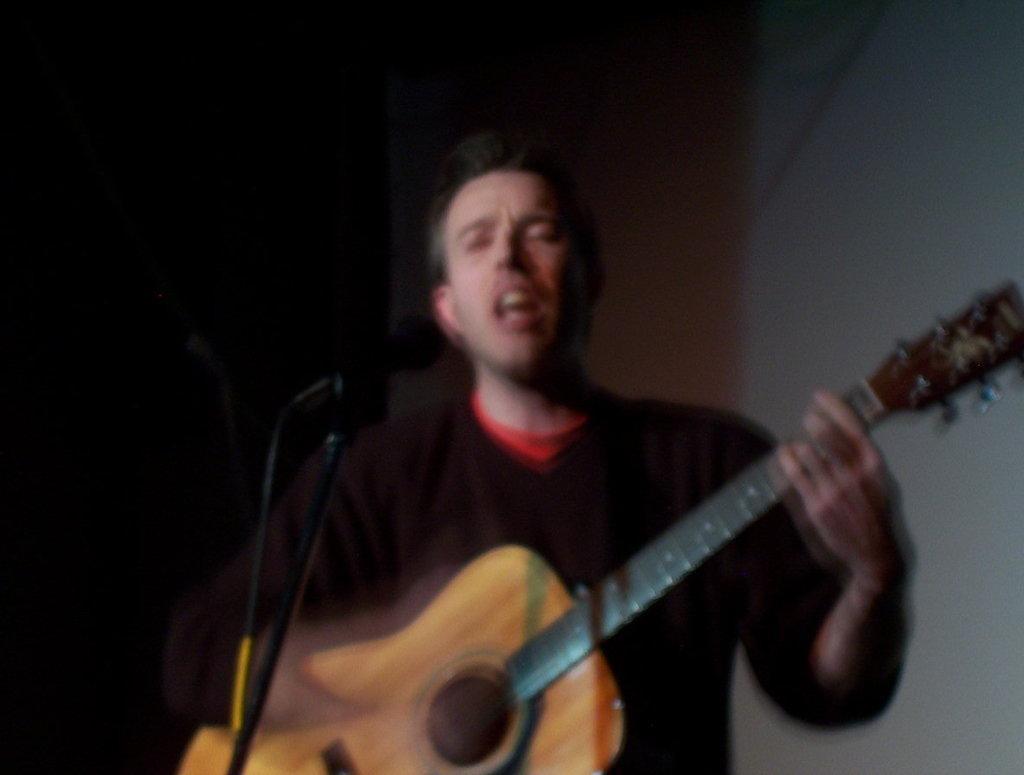In one or two sentences, can you explain what this image depicts? In the image we can see there is a person who is standing and holding guitar in his hand. 